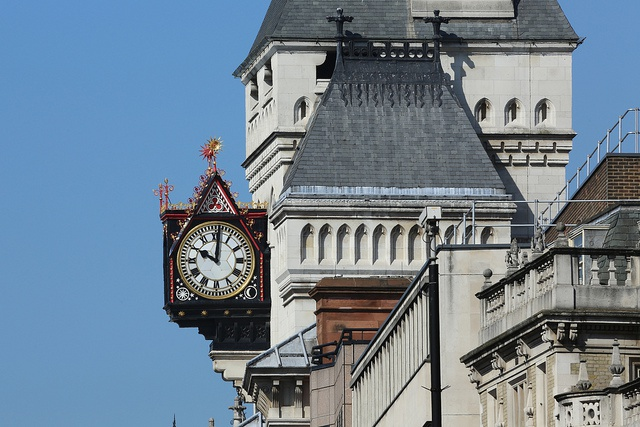Describe the objects in this image and their specific colors. I can see a clock in gray, lightgray, black, and darkgray tones in this image. 